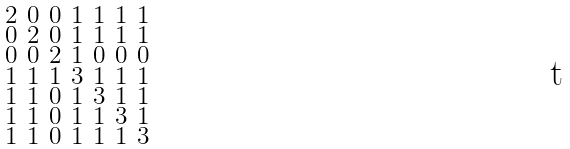Convert formula to latex. <formula><loc_0><loc_0><loc_500><loc_500>\begin{smallmatrix} 2 & 0 & 0 & 1 & 1 & 1 & 1 \\ 0 & 2 & 0 & 1 & 1 & 1 & 1 \\ 0 & 0 & 2 & 1 & 0 & 0 & 0 \\ 1 & 1 & 1 & 3 & 1 & 1 & 1 \\ 1 & 1 & 0 & 1 & 3 & 1 & 1 \\ 1 & 1 & 0 & 1 & 1 & 3 & 1 \\ 1 & 1 & 0 & 1 & 1 & 1 & 3 \end{smallmatrix}</formula> 